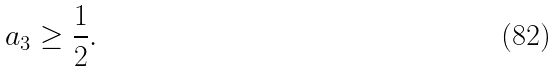<formula> <loc_0><loc_0><loc_500><loc_500>a _ { 3 } \geq \frac { 1 } { 2 } .</formula> 